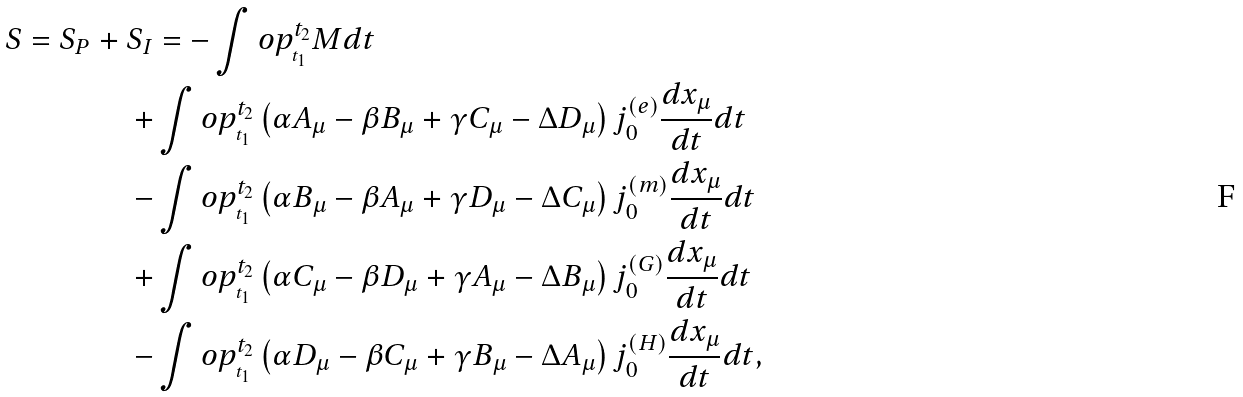Convert formula to latex. <formula><loc_0><loc_0><loc_500><loc_500>S = S _ { P } + S _ { I } & = - \int o p _ { _ { t _ { 1 } } } ^ { t _ { 2 } } M d t \\ + & \int o p _ { _ { t _ { 1 } } } ^ { t _ { 2 } } \left ( \alpha A _ { \mu } - \beta B _ { \mu } + \gamma C _ { \mu } - \Delta D _ { \mu } \right ) j _ { 0 } ^ { ( e ) } \frac { d x _ { \mu } } { d t } d t \\ - & \int o p _ { _ { t _ { 1 } } } ^ { t _ { 2 } } \left ( \alpha B _ { \mu } - \beta A _ { \mu } + \gamma D _ { \mu } - \Delta C _ { \mu } \right ) j _ { 0 } ^ { ( m ) } \frac { d x _ { \mu } } { d t } d t \\ + & \int o p _ { _ { t _ { 1 } } } ^ { t _ { 2 } } \left ( \alpha C _ { \mu } - \beta D _ { \mu } + \gamma A _ { \mu } - \Delta B _ { \mu } \right ) j _ { 0 } ^ { ( G ) } \frac { d x _ { \mu } } { d t } d t \\ - & \int o p _ { _ { t _ { 1 } } } ^ { t _ { 2 } } \left ( \alpha D _ { \mu } - \beta C _ { \mu } + \gamma B _ { \mu } - \Delta A _ { \mu } \right ) j _ { 0 } ^ { ( H ) } \frac { d x _ { \mu } } { d t } d t ,</formula> 